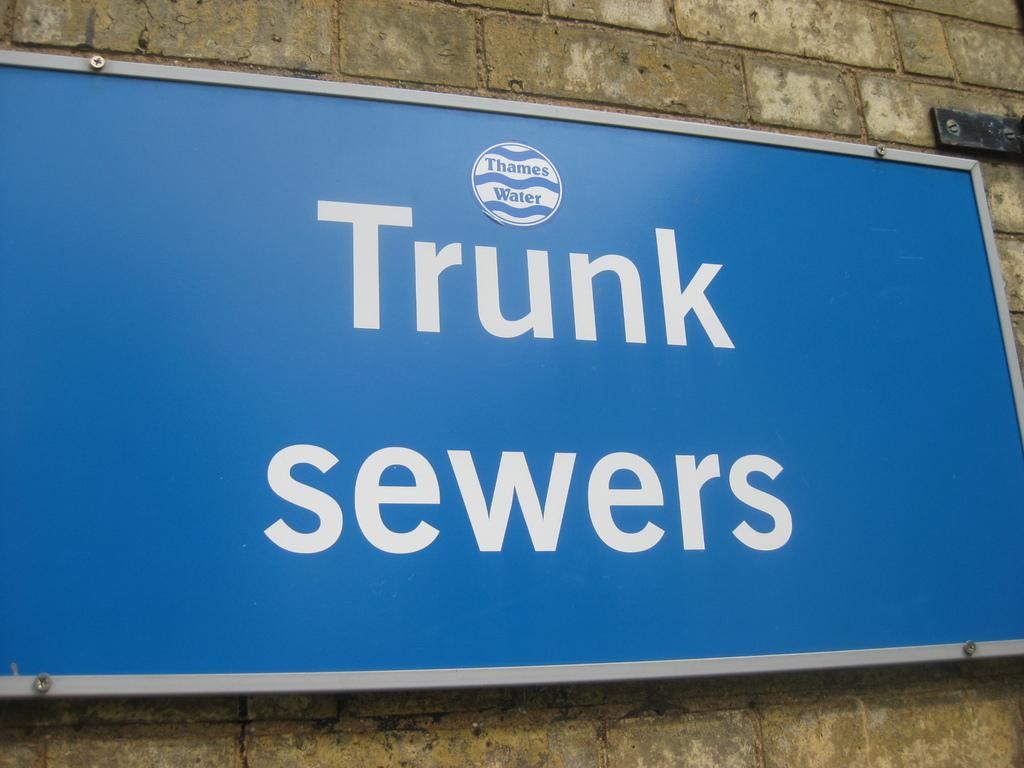What color are the letters written in ?
Offer a terse response. White. What is written below the logo in the flag?
Make the answer very short. Trunk sewers. 